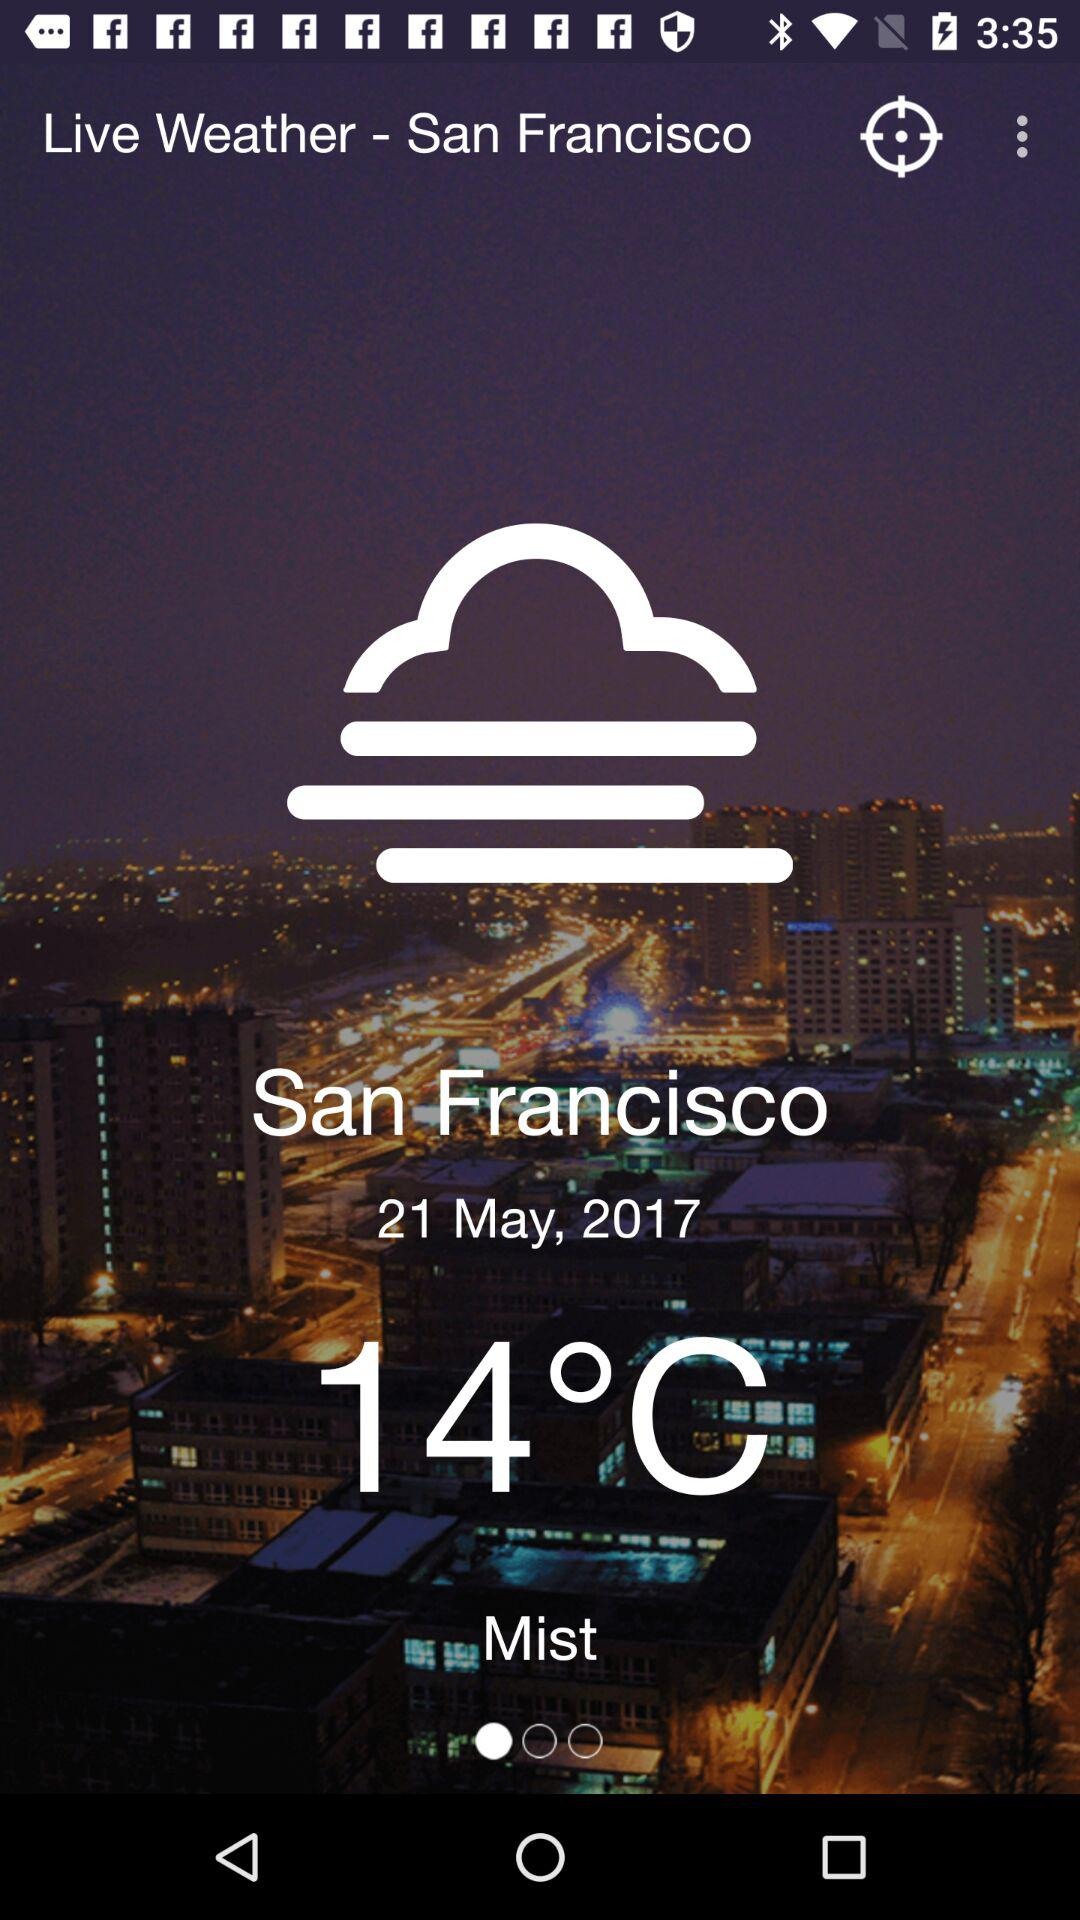What is the unit of temperature? The unit of temperature is degree Celsius. 